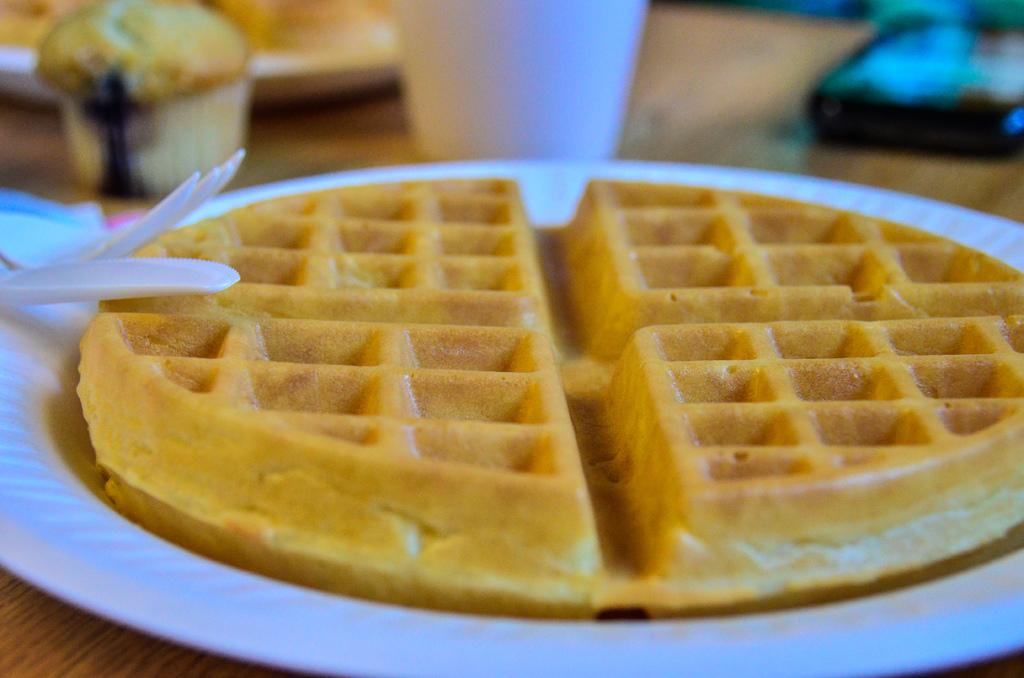What is on the plate that is visible in the image? There is food on a plate in the image. How many plates are on the table in the image? There are plates on the table in the image. What else is on the table besides plates? There is a bowl, a glass, a device, a fork, and a spoon on the table. Can you see a rabbit looking out the window in the image? There is no rabbit or window present in the image. 